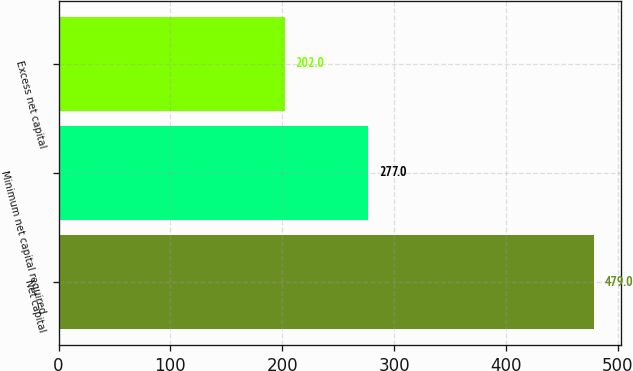Convert chart. <chart><loc_0><loc_0><loc_500><loc_500><bar_chart><fcel>Net capital<fcel>Minimum net capital required<fcel>Excess net capital<nl><fcel>479<fcel>277<fcel>202<nl></chart> 